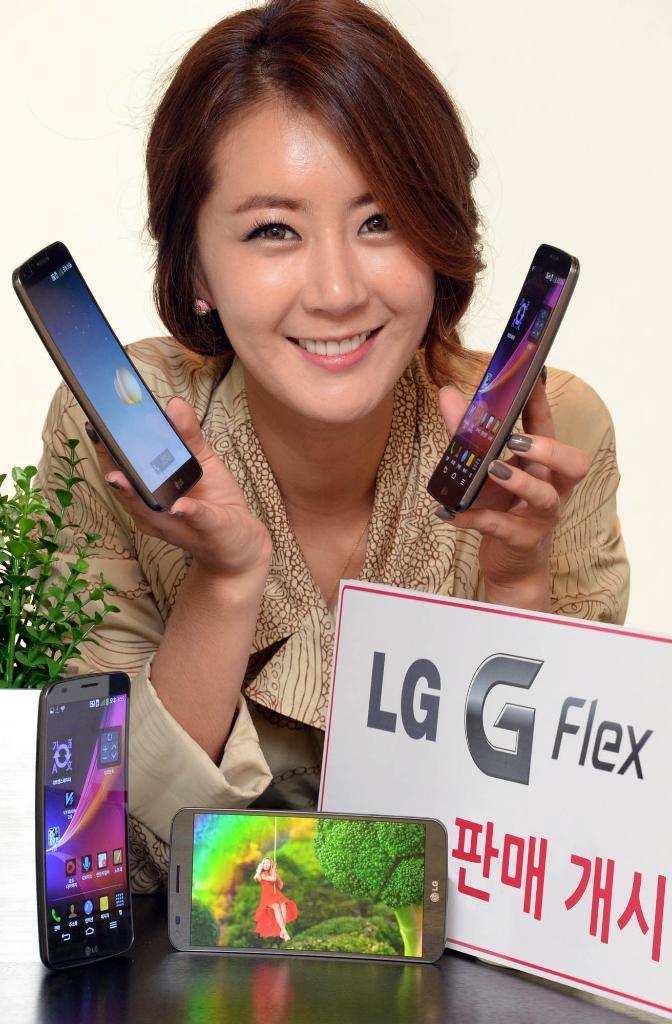Please provide a concise description of this image. In the center of the image we can see a lady is bending and smiling and holding the mobiles, in-front of her we can see a table. On the table we can see the mobiles, board and plant. On the board we can see the text. In the background of the image we can see the wall. 